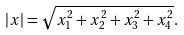Convert formula to latex. <formula><loc_0><loc_0><loc_500><loc_500>| x | = \sqrt { x _ { 1 } ^ { 2 } + x _ { 2 } ^ { 2 } + x _ { 3 } ^ { 2 } + x _ { 4 } ^ { 2 } } .</formula> 